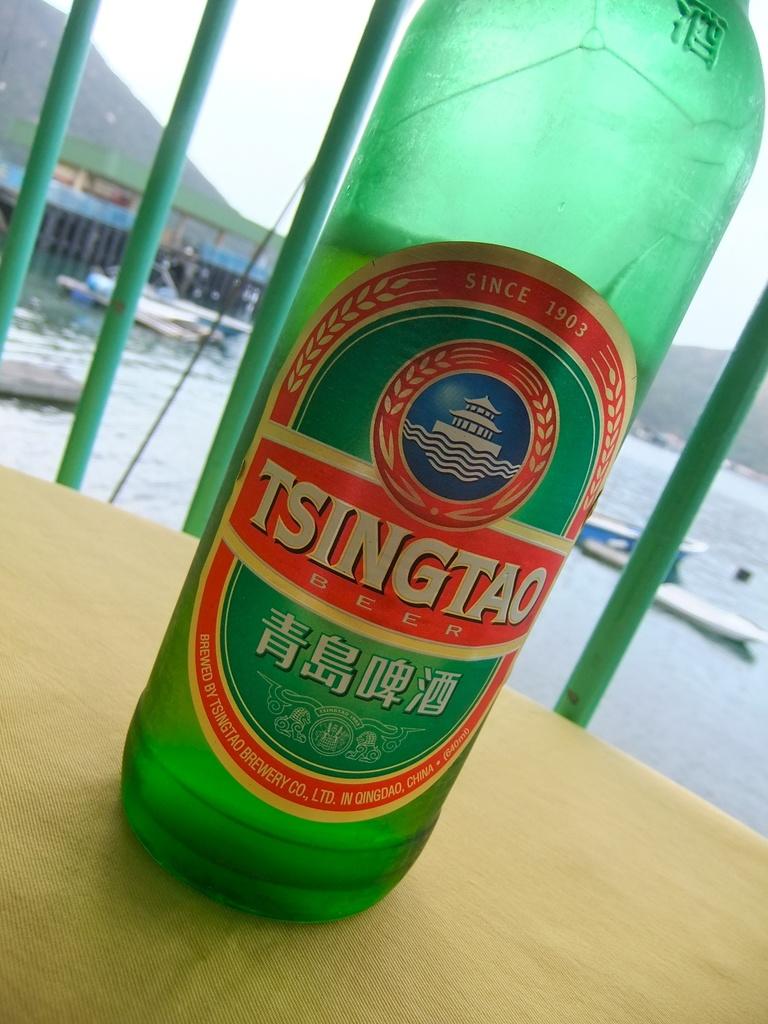What kind of drink is it?
Provide a short and direct response. Tsingtao. When was this brewery established?
Keep it short and to the point. 1903. 